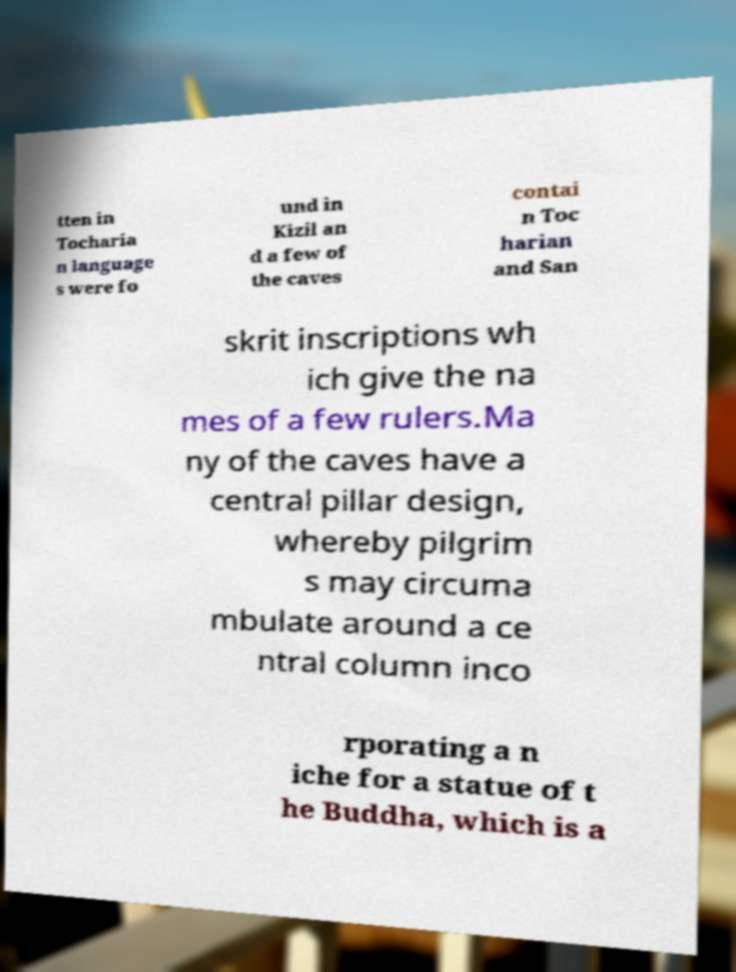Please read and relay the text visible in this image. What does it say? tten in Tocharia n language s were fo und in Kizil an d a few of the caves contai n Toc harian and San skrit inscriptions wh ich give the na mes of a few rulers.Ma ny of the caves have a central pillar design, whereby pilgrim s may circuma mbulate around a ce ntral column inco rporating a n iche for a statue of t he Buddha, which is a 